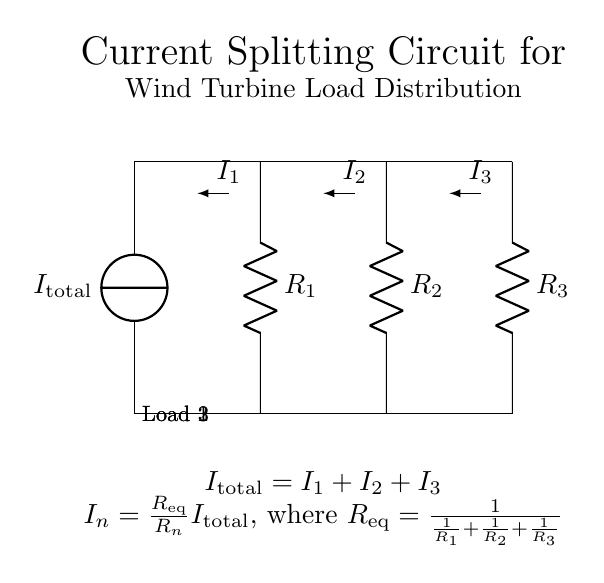What is the total current flowing into the circuit? The total current flowing into the circuit is denoted as I_total, which is the sum of the currents through each load.
Answer: I_total What are the three loads in the circuit? The three loads are represented by R1, R2, and R3, typically corresponding to battery charging, grid feed-in, and local consumption.
Answer: R1, R2, R3 What is the equation that relates total current to individual branch currents? The equation in the circuit states that I_total is equal to the sum of I1, I2, and I3, which shows how total current is divided among the branches.
Answer: I_total = I1 + I2 + I3 How does current split in relation to resistance in this circuit? The current splits inversely with the resistance; each current is proportional to the equivalent resistance and the individual resistance of the branch, which is expressed by the equation I_n = (R_eq/R_n) I_total.
Answer: Inversely proportional to resistance What role does R_eq play in the current distribution? R_eq is calculated based on the resistances of the loads and determines how the total current is divided among them, affecting the distribution of current to each load.
Answer: Determines current distribution Which load receives the least current? The load with the highest resistance will receive the least current, based on the current divider principle; thus, we compare R1, R2, and R3 to find the highest.
Answer: The highest resistance load 